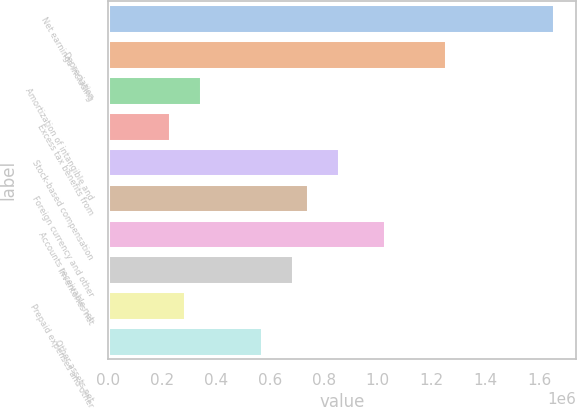Convert chart to OTSL. <chart><loc_0><loc_0><loc_500><loc_500><bar_chart><fcel>Net earnings including<fcel>Depreciation<fcel>Amortization of intangible and<fcel>Excess tax benefits from<fcel>Stock-based compensation<fcel>Foreign currency and other<fcel>Accounts receivable net<fcel>Inventories net<fcel>Prepaid expenses and other<fcel>Other assets net<nl><fcel>1.6525e+06<fcel>1.25404e+06<fcel>343270<fcel>229423<fcel>855578<fcel>741731<fcel>1.02635e+06<fcel>684808<fcel>286346<fcel>570962<nl></chart> 